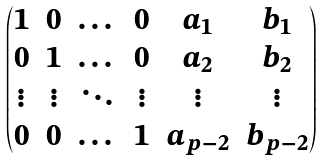Convert formula to latex. <formula><loc_0><loc_0><loc_500><loc_500>\begin{pmatrix} 1 & 0 & \dots & 0 & a _ { 1 } & b _ { 1 } \\ 0 & 1 & \dots & 0 & a _ { 2 } & b _ { 2 } \\ \vdots & \vdots & \ddots & \vdots & \vdots & \vdots \\ 0 & 0 & \dots & 1 & a _ { p - 2 } & b _ { p - 2 } \end{pmatrix}</formula> 